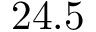Convert formula to latex. <formula><loc_0><loc_0><loc_500><loc_500>2 4 . 5</formula> 